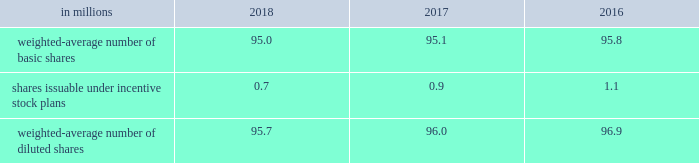Note 18 2013 earnings per share ( eps ) basic eps is calculated by dividing net earnings attributable to allegion plc by the weighted-average number of ordinary shares outstanding for the applicable period .
Diluted eps is calculated after adjusting the denominator of the basic eps calculation for the effect of all potentially dilutive ordinary shares , which in the company 2019s case , includes shares issuable under share-based compensation plans .
The table summarizes the weighted-average number of ordinary shares outstanding for basic and diluted earnings per share calculations: .
At december 31 , 2018 , 0.1 million stock options were excluded from the computation of weighted-average diluted shares outstanding because the effect of including these shares would have been anti-dilutive .
Note 19 2013 net revenues net revenues are recognized based on the satisfaction of performance obligations under the terms of a contract .
A performance obligation is a promise in a contract to transfer control of a distinct product or to provide a service , or a bundle of products or services , to a customer , and is the unit of account under asc 606 .
The company has two principal revenue streams , tangible product sales and services .
Approximately 99% ( 99 % ) of consolidated net revenues involve contracts with a single performance obligation , which is the transfer of control of a product or bundle of products to a customer .
Transfer of control typically occurs when goods are shipped from the company's facilities or at other predetermined control transfer points ( for instance , destination terms ) .
Net revenues are measured as the amount of consideration expected to be received in exchange for transferring control of the products and takes into account variable consideration , such as sales incentive programs including discounts and volume rebates .
The existence of these programs does not preclude revenue recognition but does require the company's best estimate of the variable consideration to be made based on expected activity , as these items are reserved for as a deduction to net revenues over time based on the company's historical rates of providing these incentives and annual forecasted sales volumes .
The company also offers a standard warranty with most product sales and the value of such warranty is included in the contractual price .
The corresponding cost of the warranty obligation is accrued as a liability ( see note 20 ) .
The company's remaining net revenues involve services , including installation and consulting .
Unlike the single performance obligation to ship a product or bundle of products , the service revenue stream delays revenue recognition until the service performance obligations are satisfied .
In some instances , customer acceptance provisions are included in sales arrangements to give the buyer the ability to ensure the service meets the criteria established in the order .
In these instances , revenue recognition is deferred until the performance obligations are satisfied , which could include acceptance terms specified in the arrangement being fulfilled through customer acceptance or a demonstration that established criteria have been satisfied .
During the year ended december 31 , 2018 , no adjustments related to performance obligations satisfied in previous periods were recorded .
Upon adoption of asc 606 , the company used the practical expedients to omit the disclosure of remaining performance obligations for contracts with an original expected duration of one year or less and for contracts where the company has the right to invoice for performance completed to date .
The transaction price is not adjusted for the effects of a significant financing component , as the time period between control transfer of goods and services is less than one year .
Sales , value-added and other similar taxes collected by the company are excluded from net revenues .
The company has also elected to account for shipping and handling activities that occur after control of the related goods transfers as fulfillment activities instead of performance obligations .
These activities are included in cost of goods sold in the consolidated statements of comprehensive income .
The company 2019s payment terms are generally consistent with the industries in which their businesses operate .
The following table shows the company's net revenues for the years ended december 31 , based on the two principal revenue streams , tangible product sales and services , disaggregated by business segment .
Net revenues are shown by tangible product sales and services , as contract terms , conditions and economic factors affecting the nature , amount , timing and uncertainty around revenue recognition and cash flows are substantially similar within each of the two principal revenue streams: .
Considering the years 2017-2018 , what is the decrease observed in the weighted-average number of diluted shares? 
Rationale: it is the final value ( 95.7 ) minus the initial value ( 96 ) , then divided by the initial one and turned into a percentage to represent the decrease .
Computations: (((95.7 - 96.0) / 96.0) * 100)
Answer: -0.3125. 